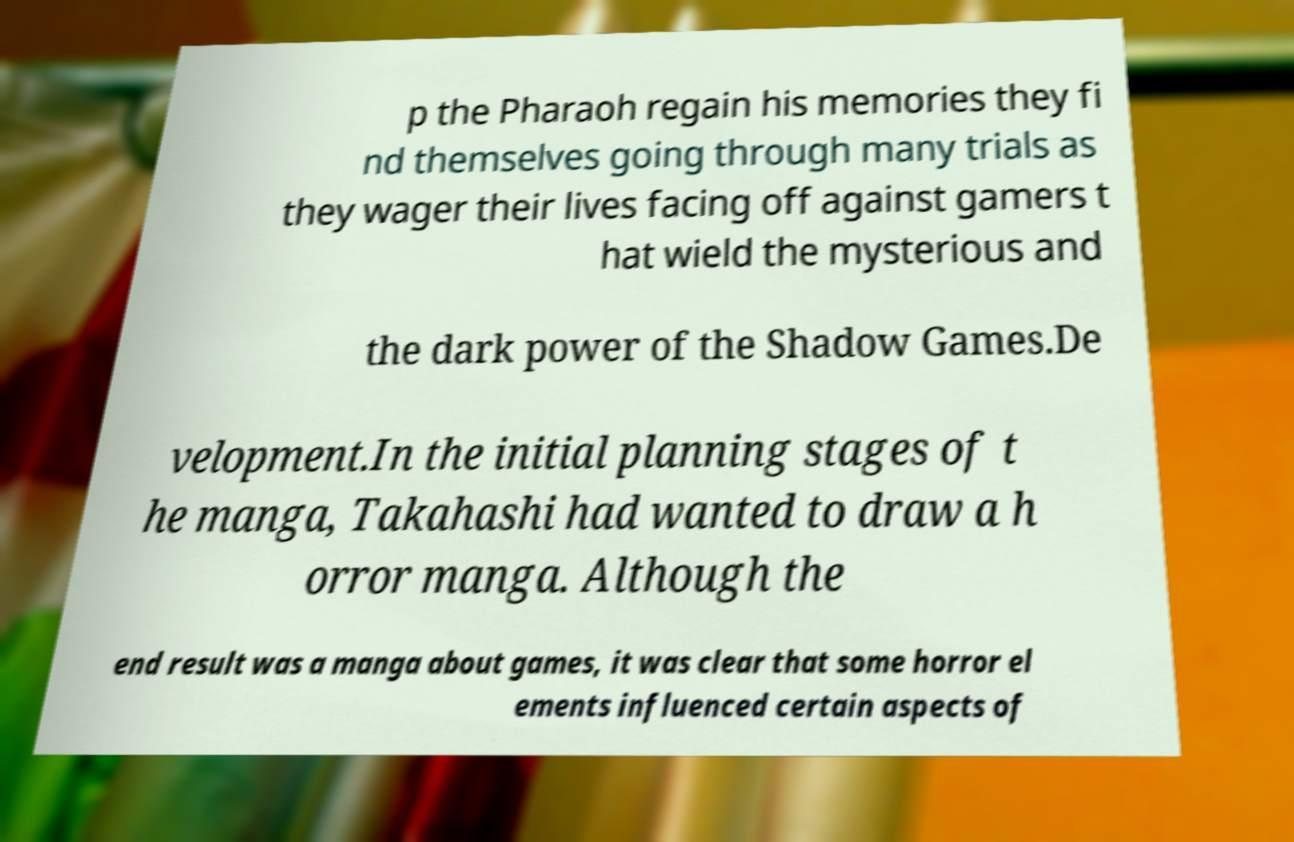Could you assist in decoding the text presented in this image and type it out clearly? p the Pharaoh regain his memories they fi nd themselves going through many trials as they wager their lives facing off against gamers t hat wield the mysterious and the dark power of the Shadow Games.De velopment.In the initial planning stages of t he manga, Takahashi had wanted to draw a h orror manga. Although the end result was a manga about games, it was clear that some horror el ements influenced certain aspects of 